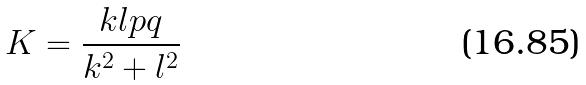<formula> <loc_0><loc_0><loc_500><loc_500>K = \frac { k l p q } { k ^ { 2 } + l ^ { 2 } }</formula> 